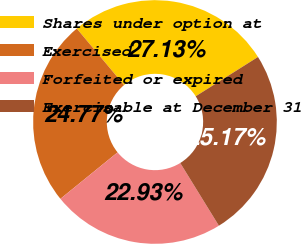<chart> <loc_0><loc_0><loc_500><loc_500><pie_chart><fcel>Shares under option at<fcel>Exercised<fcel>Forfeited or expired<fcel>Exercisable at December 31<nl><fcel>27.13%<fcel>24.77%<fcel>22.93%<fcel>25.17%<nl></chart> 